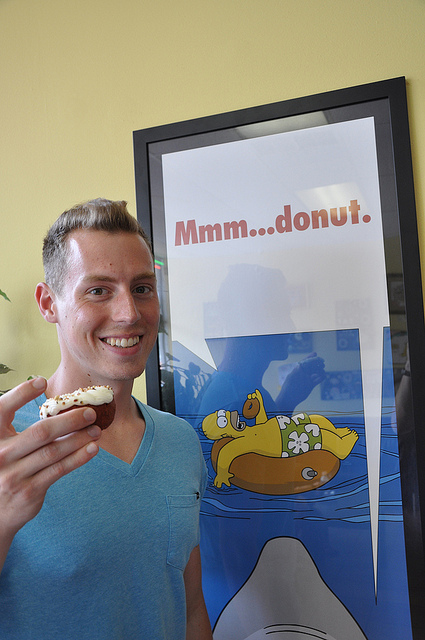<image>What day does the sign say it is? The sign does not specify a day. However, it might mention 'donut day'. Is this photograph film or digital? I am not sure if this photograph is film or digital. It could be either. What day does the sign say it is? There is no day mentioned in the sign. Is this photograph film or digital? I am not sure if the photograph is film or digital. But it can be seen digital. 